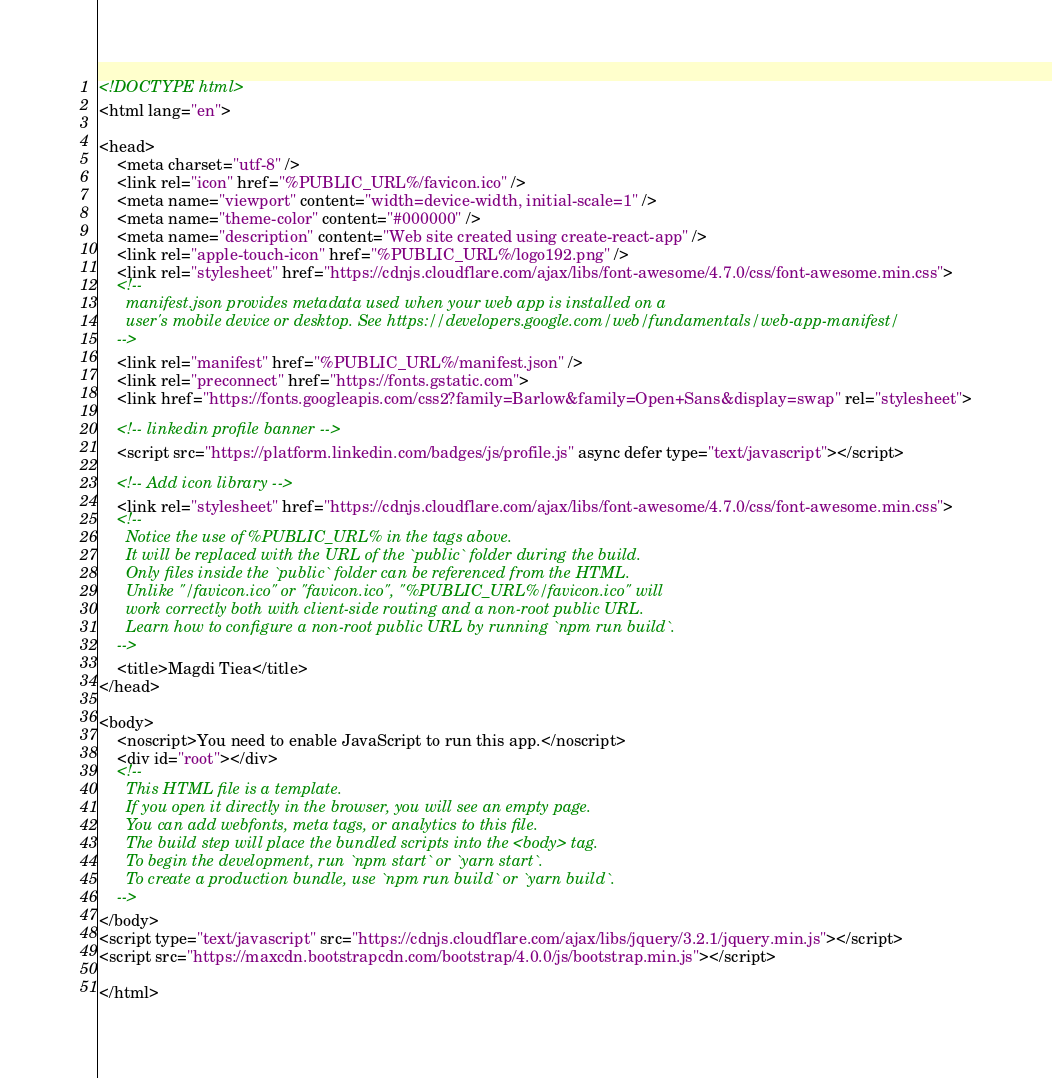Convert code to text. <code><loc_0><loc_0><loc_500><loc_500><_HTML_><!DOCTYPE html>
<html lang="en">

<head>
    <meta charset="utf-8" />
    <link rel="icon" href="%PUBLIC_URL%/favicon.ico" />
    <meta name="viewport" content="width=device-width, initial-scale=1" />
    <meta name="theme-color" content="#000000" />
    <meta name="description" content="Web site created using create-react-app" />
    <link rel="apple-touch-icon" href="%PUBLIC_URL%/logo192.png" />
    <link rel="stylesheet" href="https://cdnjs.cloudflare.com/ajax/libs/font-awesome/4.7.0/css/font-awesome.min.css">
    <!--
      manifest.json provides metadata used when your web app is installed on a
      user's mobile device or desktop. See https://developers.google.com/web/fundamentals/web-app-manifest/
    -->
    <link rel="manifest" href="%PUBLIC_URL%/manifest.json" />
    <link rel="preconnect" href="https://fonts.gstatic.com">
    <link href="https://fonts.googleapis.com/css2?family=Barlow&family=Open+Sans&display=swap" rel="stylesheet">

    <!-- linkedin profile banner -->
    <script src="https://platform.linkedin.com/badges/js/profile.js" async defer type="text/javascript"></script>

    <!-- Add icon library -->
    <link rel="stylesheet" href="https://cdnjs.cloudflare.com/ajax/libs/font-awesome/4.7.0/css/font-awesome.min.css">
    <!--
      Notice the use of %PUBLIC_URL% in the tags above.
      It will be replaced with the URL of the `public` folder during the build.
      Only files inside the `public` folder can be referenced from the HTML.
      Unlike "/favicon.ico" or "favicon.ico", "%PUBLIC_URL%/favicon.ico" will
      work correctly both with client-side routing and a non-root public URL.
      Learn how to configure a non-root public URL by running `npm run build`.
    -->
    <title>Magdi Tiea</title>
</head>

<body>
    <noscript>You need to enable JavaScript to run this app.</noscript>
    <div id="root"></div>
    <!--
      This HTML file is a template.
      If you open it directly in the browser, you will see an empty page.
      You can add webfonts, meta tags, or analytics to this file.
      The build step will place the bundled scripts into the <body> tag.
      To begin the development, run `npm start` or `yarn start`.
      To create a production bundle, use `npm run build` or `yarn build`.
    -->
</body>
<script type="text/javascript" src="https://cdnjs.cloudflare.com/ajax/libs/jquery/3.2.1/jquery.min.js"></script>
<script src="https://maxcdn.bootstrapcdn.com/bootstrap/4.0.0/js/bootstrap.min.js"></script>

</html></code> 